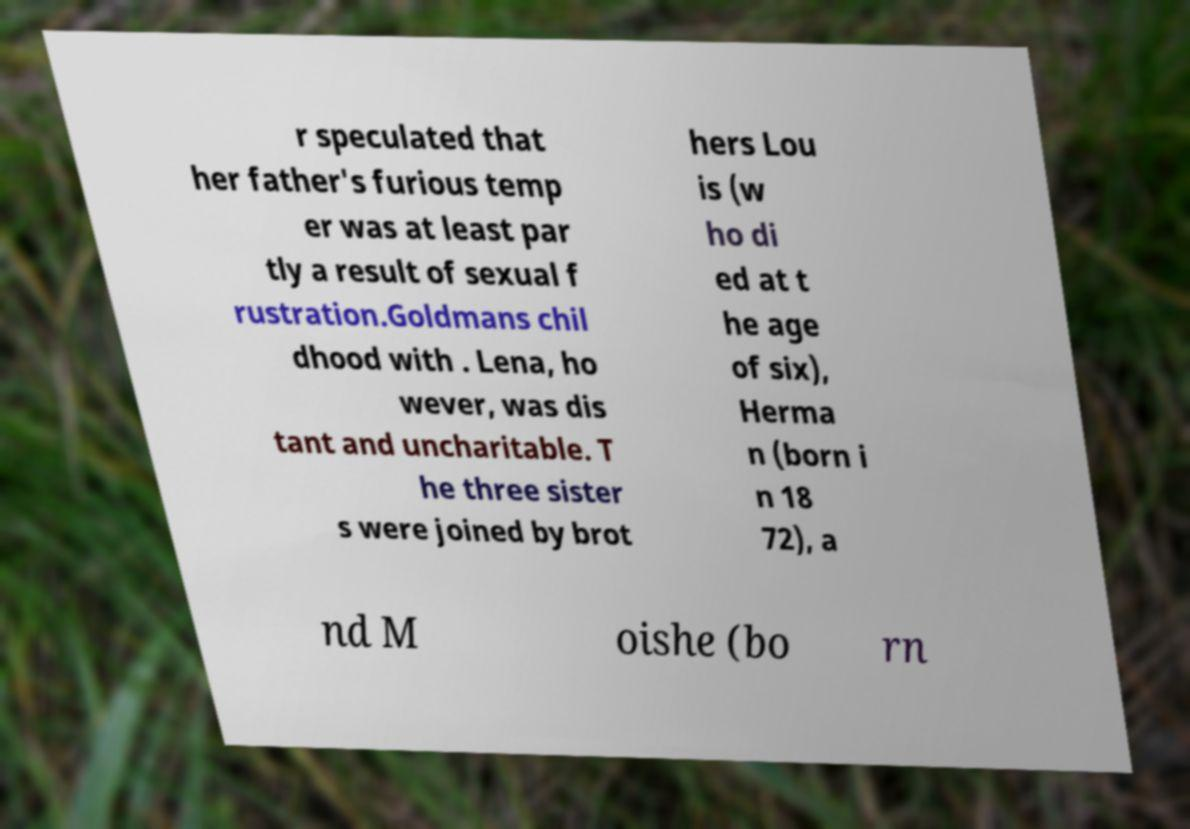For documentation purposes, I need the text within this image transcribed. Could you provide that? r speculated that her father's furious temp er was at least par tly a result of sexual f rustration.Goldmans chil dhood with . Lena, ho wever, was dis tant and uncharitable. T he three sister s were joined by brot hers Lou is (w ho di ed at t he age of six), Herma n (born i n 18 72), a nd M oishe (bo rn 